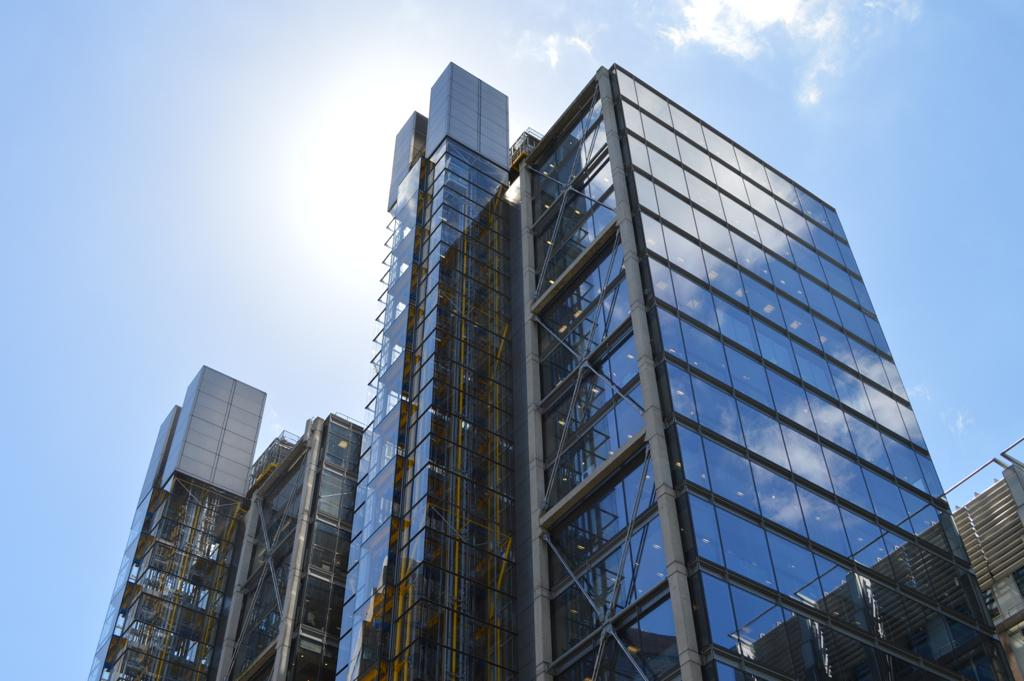What is the person in the picture doing? The person is sitting at a desk working on a laptop. What objects are present on the desk? The desk has a lamp and a cup of coffee. What might the person be using the lamp for? The person might be using the lamp for additional light while working on the laptop. What is the purpose of the cup of coffee on the desk? The cup of coffee might be for the person to drink while working, providing them with energy or comfort. What type of reward can be seen hanging from the lamp on the desk? There is no reward hanging from the lamp on the desk; it is a lamp used for providing light. 